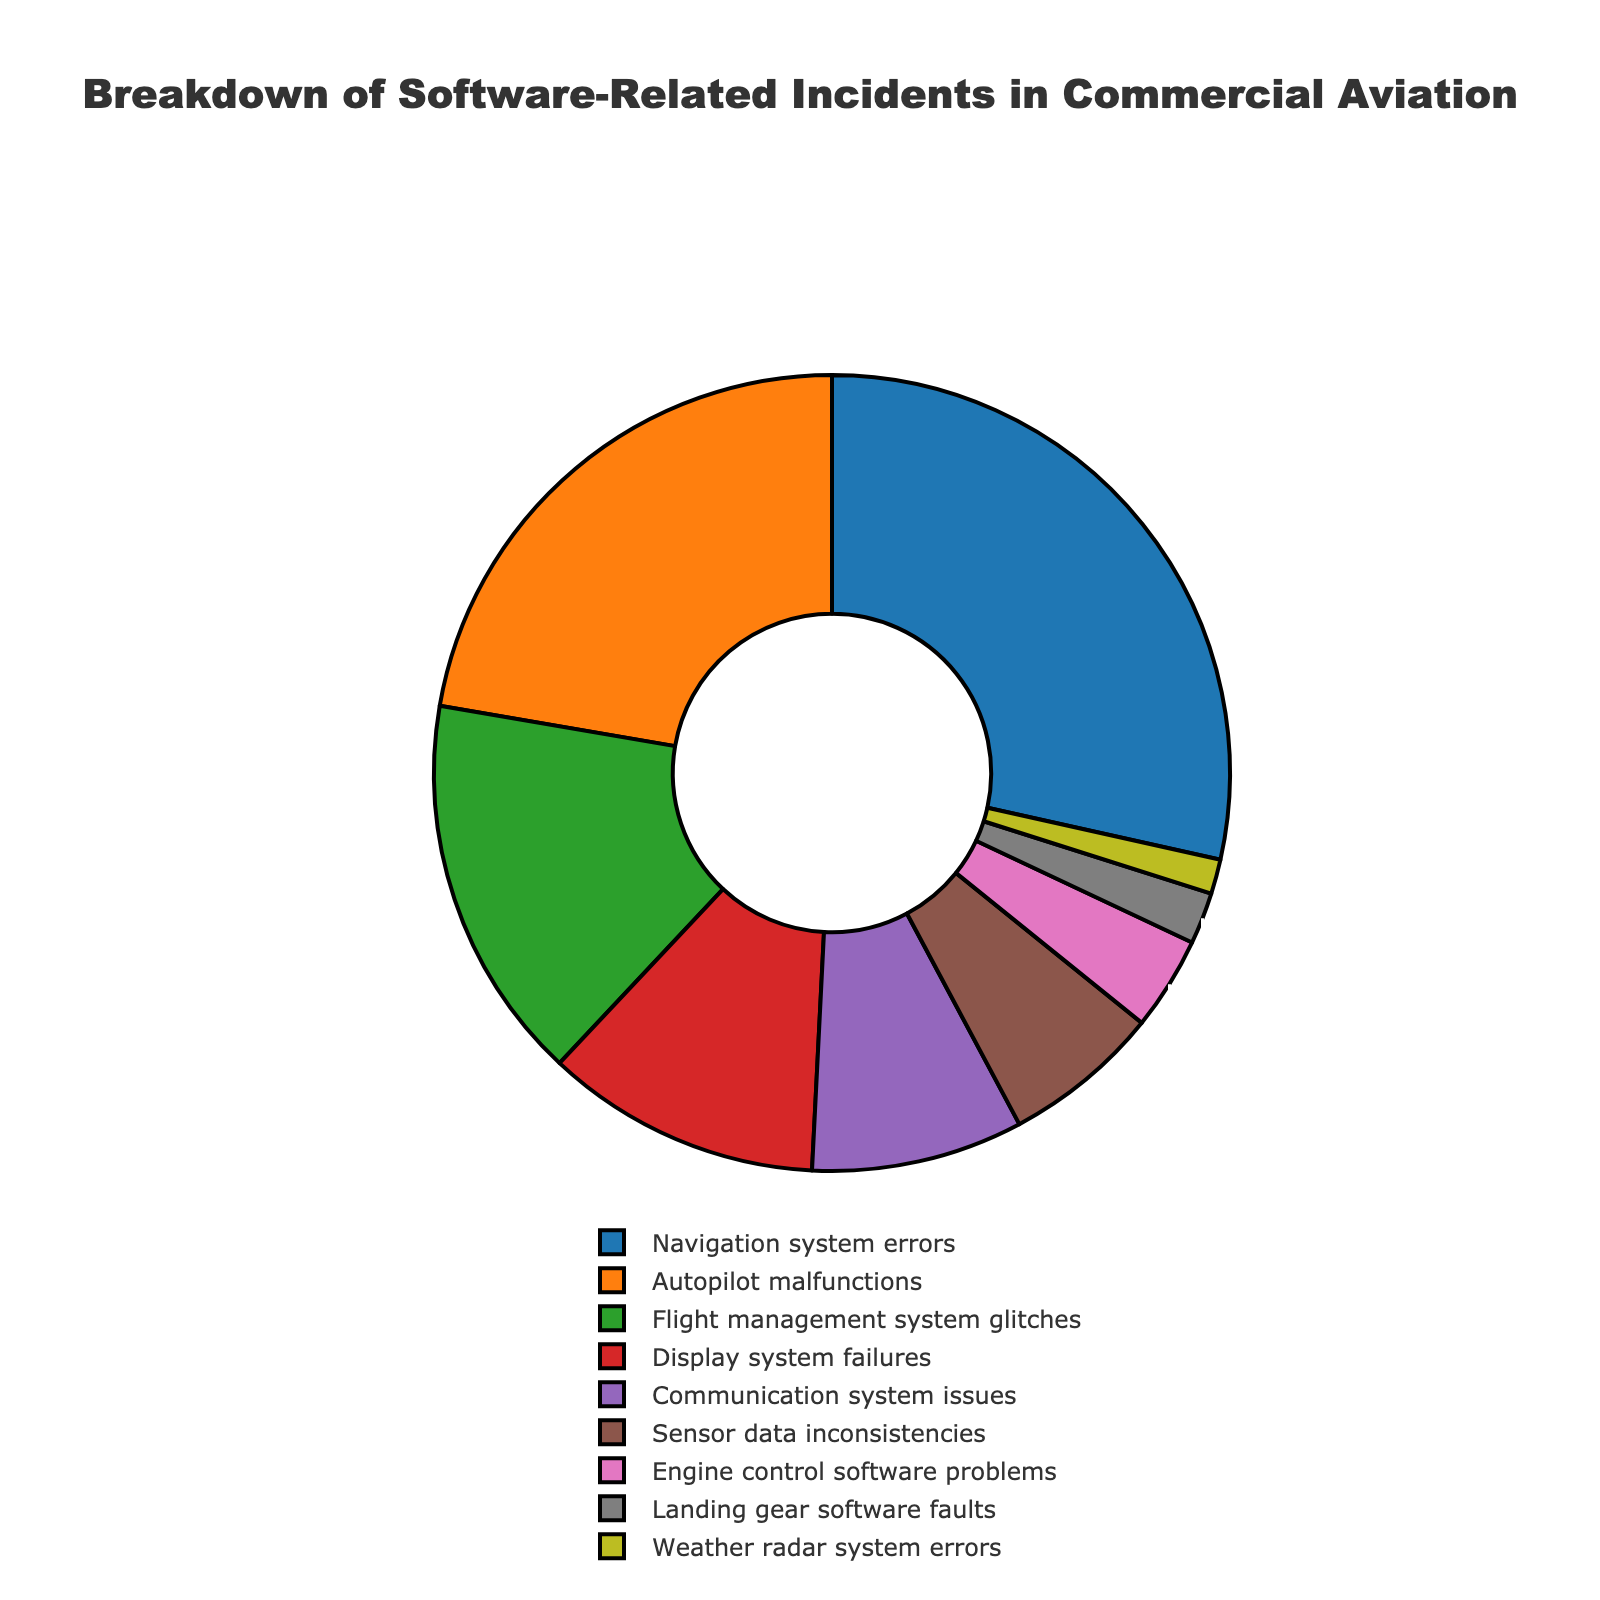What is the percentage of software-related incidents caused by navigation system errors? According to the figure, the slice labeled "Navigation system errors" shows a value of 28.5%.
Answer: 28.5% Which category has the second-highest percentage of incidents? By observing the size of the slices and their labels, "Autopilot malfunctions" is the second-largest slice after "Navigation system errors," showing a value of 22.3%.
Answer: Autopilot malfunctions What is the combined percentage of incidents caused by display system failures and communication system issues? Add the values for "Display system failures" (11.2%) and "Communication system issues" (8.6%). So, 11.2% + 8.6% = 19.8%.
Answer: 19.8% How does the percentage of flight management system glitches compare to sensor data inconsistencies? The value for "Flight management system glitches" is 15.7%, whereas "Sensor data inconsistencies" is 6.4%. Therefore, flight management system glitches have a higher percentage.
Answer: Flight management system glitches have a higher percentage Which category has the lowest percentage of incidents, and what is that percentage? The smallest slice on the pie chart is labeled "Weather radar system errors" with a value of 1.4%.
Answer: Weather radar system errors, 1.4% Is the percentage of incidents related to engine control software problems greater than, less than, or equal to landing gear software faults? The value for "Engine control software problems" (3.8%) is compared with "Landing gear software faults" (2.1%). Since 3.8% > 2.1%, engine control software problems have a greater percentage.
Answer: Greater What is the sum of the percentages for the top three categories in software-related incidents? Find the sum of the top three categories: "Navigation system errors" (28.5%), "Autopilot malfunctions" (22.3%), and "Flight management system glitches" (15.7%). So, 28.5% + 22.3% + 15.7% = 66.5%.
Answer: 66.5% What visual element indicates the category with the highest percentage of incidents? The category "Navigation system errors" has the largest slice in the pie chart, which visually indicates its highest percentage.
Answer: Largest slice 